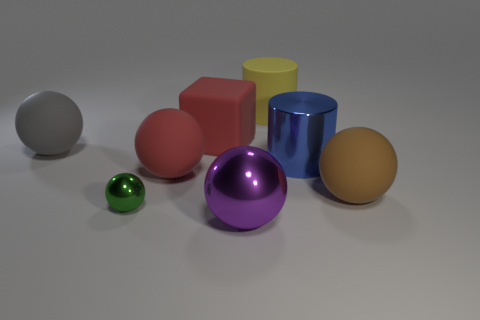Subtract all large rubber spheres. How many spheres are left? 2 Add 1 big yellow rubber objects. How many objects exist? 9 Subtract all balls. How many objects are left? 3 Subtract 1 cylinders. How many cylinders are left? 1 Add 2 large red objects. How many large red objects exist? 4 Subtract all green balls. How many balls are left? 4 Subtract 0 green blocks. How many objects are left? 8 Subtract all green cubes. Subtract all cyan balls. How many cubes are left? 1 Subtract all red objects. Subtract all small green objects. How many objects are left? 5 Add 2 brown balls. How many brown balls are left? 3 